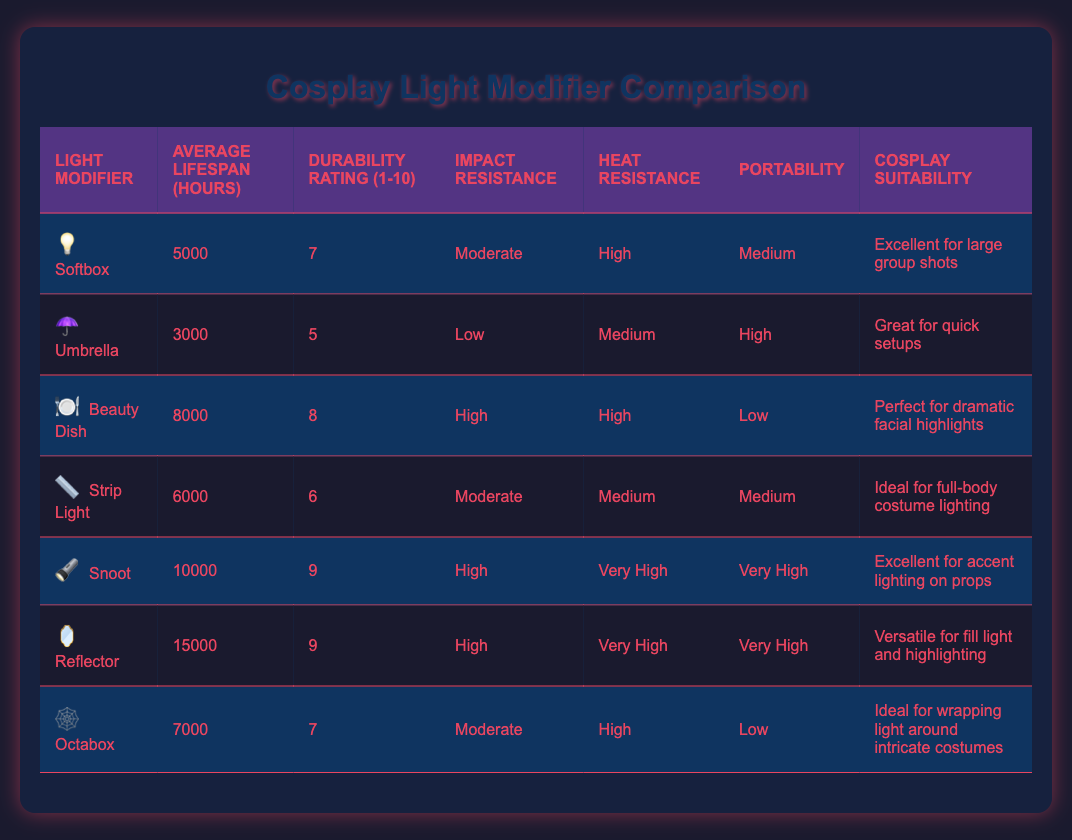What is the average lifespan of a Softbox? The table shows that the average lifespan of a Softbox is 5000 hours. This value is directly available in the "Average Lifespan (hours)" column for Softbox.
Answer: 5000 hours Which light modifier has the highest durability rating? By looking at the "Durability Rating (1-10)" column, Snoot and Reflector both have the highest rating of 9. This is the highest value compared to the others in the list.
Answer: Snoot and Reflector Is the Umbrella suitable for large group shots? The table indicates that the Umbrella is marked as "Great for quick setups" under the "Cosplay Suitability" column, which suggests it is not particularly suited for large group shots.
Answer: No What is the difference in average lifespan between the Beauty Dish and the Strip Light? The average lifespan of the Beauty Dish is 8000 hours, while the Strip Light has a lifespan of 6000 hours. The difference can be calculated as 8000 - 6000 = 2000 hours.
Answer: 2000 hours Which light modifiers have high impact resistance? By scanning the "Impact Resistance" column, both the Beauty Dish, Snoot, and Reflector are labeled as having "High" impact resistance. This indicates they can withstand more stress without damage.
Answer: Beauty Dish, Snoot, Reflector What is the average durability rating of all the light modifiers listed? To find the average durability rating, we sum the ratings: (7 + 5 + 8 + 6 + 9 + 9 + 7) = 51. Then, we divide by the total number of modifiers, which is 7. 51/7 = 7.29, which can be rounded to approximately 7.3.
Answer: 7.3 Does the Octabox have the lowest durability rating? In the "Durability Rating (1-10)" column, the Octabox has a rating of 7. When reviewing other ratings in the table, Umbrella has the lowest at 5. Therefore, the Octabox does not have the lowest rating.
Answer: No Which modifier is the best for accent lighting on props? According to the "Cosplay Suitability" column, Snoot is listed as "Excellent for accent lighting on props," making it the best choice for this specific purpose among the modifiers.
Answer: Snoot How many light modifiers have a heat resistance of high or higher? Referring to the "Heat Resistance" column, the Softbox, Beauty Dish, Snoot, and Reflector are marked as "High" or "Very High," totaling four modifiers.
Answer: 4 